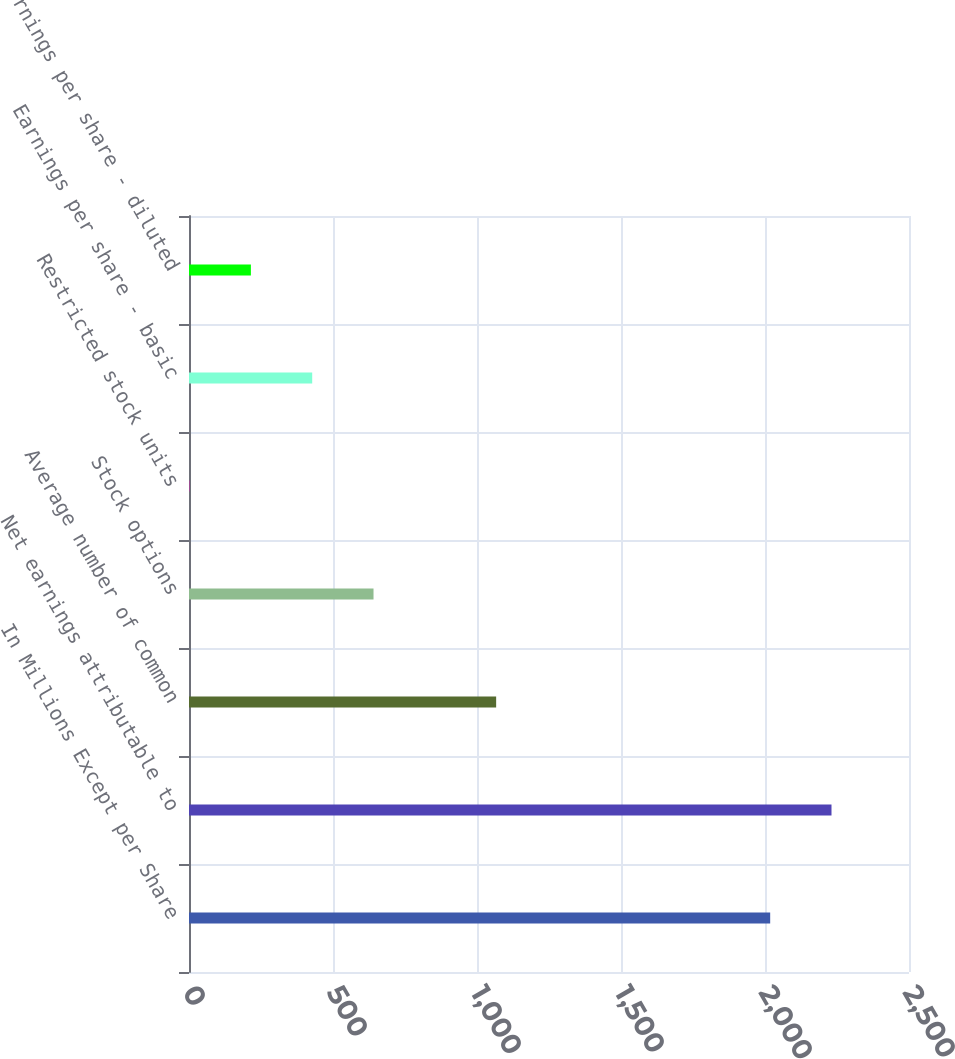Convert chart to OTSL. <chart><loc_0><loc_0><loc_500><loc_500><bar_chart><fcel>In Millions Except per Share<fcel>Net earnings attributable to<fcel>Average number of common<fcel>Stock options<fcel>Restricted stock units<fcel>Earnings per share - basic<fcel>Earnings per share - diluted<nl><fcel>2018<fcel>2230.9<fcel>1066.5<fcel>640.7<fcel>2<fcel>427.8<fcel>214.9<nl></chart> 